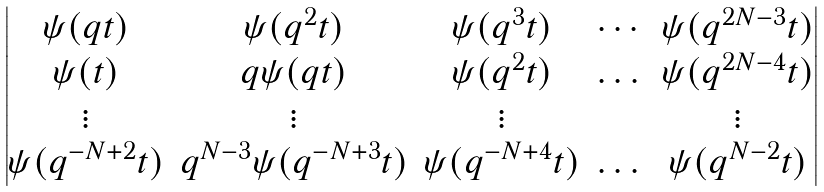Convert formula to latex. <formula><loc_0><loc_0><loc_500><loc_500>\begin{vmatrix} \psi ( q t ) & \psi ( q ^ { 2 } t ) & \psi ( q ^ { 3 } t ) & \cdots & \psi ( q ^ { 2 N - 3 } t ) \\ \psi ( t ) & q \psi ( q t ) & \psi ( q ^ { 2 } t ) & \dots & \psi ( q ^ { 2 N - 4 } t ) \\ \vdots & \vdots & \vdots & \quad & \vdots \\ \psi ( q ^ { - N + 2 } t ) & q ^ { N - 3 } \psi ( q ^ { - N + 3 } t ) & \psi ( q ^ { - N + 4 } t ) & \dots & \psi ( q ^ { N - 2 } t ) \end{vmatrix}</formula> 